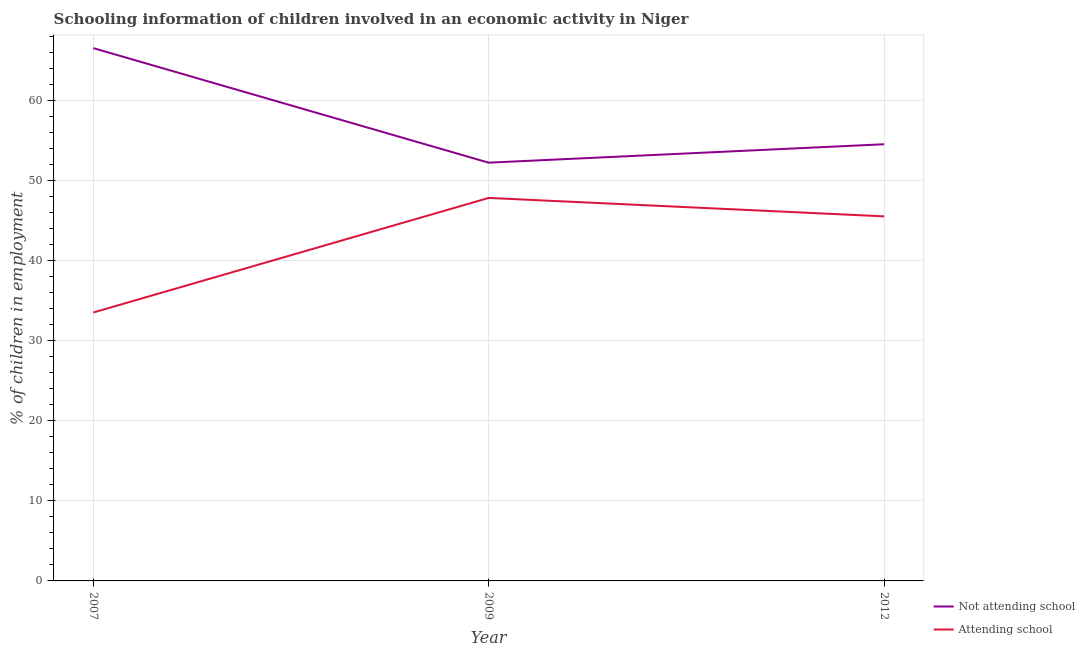Is the number of lines equal to the number of legend labels?
Give a very brief answer. Yes. What is the percentage of employed children who are not attending school in 2012?
Keep it short and to the point. 54.5. Across all years, what is the maximum percentage of employed children who are attending school?
Your answer should be very brief. 47.8. Across all years, what is the minimum percentage of employed children who are not attending school?
Make the answer very short. 52.2. In which year was the percentage of employed children who are not attending school minimum?
Provide a short and direct response. 2009. What is the total percentage of employed children who are not attending school in the graph?
Offer a terse response. 173.2. What is the difference between the percentage of employed children who are attending school in 2007 and that in 2009?
Make the answer very short. -14.3. What is the average percentage of employed children who are not attending school per year?
Your answer should be very brief. 57.73. What is the ratio of the percentage of employed children who are attending school in 2007 to that in 2009?
Your answer should be compact. 0.7. Is the percentage of employed children who are attending school in 2009 less than that in 2012?
Give a very brief answer. No. What is the difference between the highest and the lowest percentage of employed children who are attending school?
Make the answer very short. 14.3. Does the percentage of employed children who are not attending school monotonically increase over the years?
Offer a terse response. No. Is the percentage of employed children who are not attending school strictly greater than the percentage of employed children who are attending school over the years?
Offer a very short reply. Yes. How many lines are there?
Offer a terse response. 2. How many years are there in the graph?
Provide a succinct answer. 3. What is the difference between two consecutive major ticks on the Y-axis?
Ensure brevity in your answer.  10. Does the graph contain grids?
Your answer should be very brief. Yes. How many legend labels are there?
Make the answer very short. 2. What is the title of the graph?
Your answer should be compact. Schooling information of children involved in an economic activity in Niger. Does "Secondary" appear as one of the legend labels in the graph?
Your response must be concise. No. What is the label or title of the Y-axis?
Ensure brevity in your answer.  % of children in employment. What is the % of children in employment in Not attending school in 2007?
Offer a terse response. 66.5. What is the % of children in employment in Attending school in 2007?
Provide a succinct answer. 33.5. What is the % of children in employment of Not attending school in 2009?
Provide a succinct answer. 52.2. What is the % of children in employment in Attending school in 2009?
Your answer should be very brief. 47.8. What is the % of children in employment of Not attending school in 2012?
Offer a very short reply. 54.5. What is the % of children in employment of Attending school in 2012?
Your answer should be compact. 45.5. Across all years, what is the maximum % of children in employment in Not attending school?
Your response must be concise. 66.5. Across all years, what is the maximum % of children in employment in Attending school?
Keep it short and to the point. 47.8. Across all years, what is the minimum % of children in employment in Not attending school?
Give a very brief answer. 52.2. Across all years, what is the minimum % of children in employment of Attending school?
Your answer should be compact. 33.5. What is the total % of children in employment in Not attending school in the graph?
Offer a terse response. 173.2. What is the total % of children in employment of Attending school in the graph?
Make the answer very short. 126.8. What is the difference between the % of children in employment of Not attending school in 2007 and that in 2009?
Your response must be concise. 14.3. What is the difference between the % of children in employment of Attending school in 2007 and that in 2009?
Give a very brief answer. -14.3. What is the difference between the % of children in employment of Not attending school in 2007 and that in 2012?
Provide a short and direct response. 12. What is the difference between the % of children in employment of Not attending school in 2007 and the % of children in employment of Attending school in 2009?
Keep it short and to the point. 18.7. What is the difference between the % of children in employment in Not attending school in 2007 and the % of children in employment in Attending school in 2012?
Keep it short and to the point. 21. What is the difference between the % of children in employment in Not attending school in 2009 and the % of children in employment in Attending school in 2012?
Provide a short and direct response. 6.7. What is the average % of children in employment of Not attending school per year?
Your answer should be very brief. 57.73. What is the average % of children in employment of Attending school per year?
Offer a very short reply. 42.27. In the year 2007, what is the difference between the % of children in employment of Not attending school and % of children in employment of Attending school?
Provide a succinct answer. 33. In the year 2009, what is the difference between the % of children in employment of Not attending school and % of children in employment of Attending school?
Offer a terse response. 4.4. What is the ratio of the % of children in employment of Not attending school in 2007 to that in 2009?
Your response must be concise. 1.27. What is the ratio of the % of children in employment in Attending school in 2007 to that in 2009?
Provide a short and direct response. 0.7. What is the ratio of the % of children in employment of Not attending school in 2007 to that in 2012?
Keep it short and to the point. 1.22. What is the ratio of the % of children in employment in Attending school in 2007 to that in 2012?
Offer a very short reply. 0.74. What is the ratio of the % of children in employment of Not attending school in 2009 to that in 2012?
Your answer should be compact. 0.96. What is the ratio of the % of children in employment in Attending school in 2009 to that in 2012?
Your answer should be very brief. 1.05. What is the difference between the highest and the second highest % of children in employment of Attending school?
Keep it short and to the point. 2.3. What is the difference between the highest and the lowest % of children in employment in Not attending school?
Offer a terse response. 14.3. 